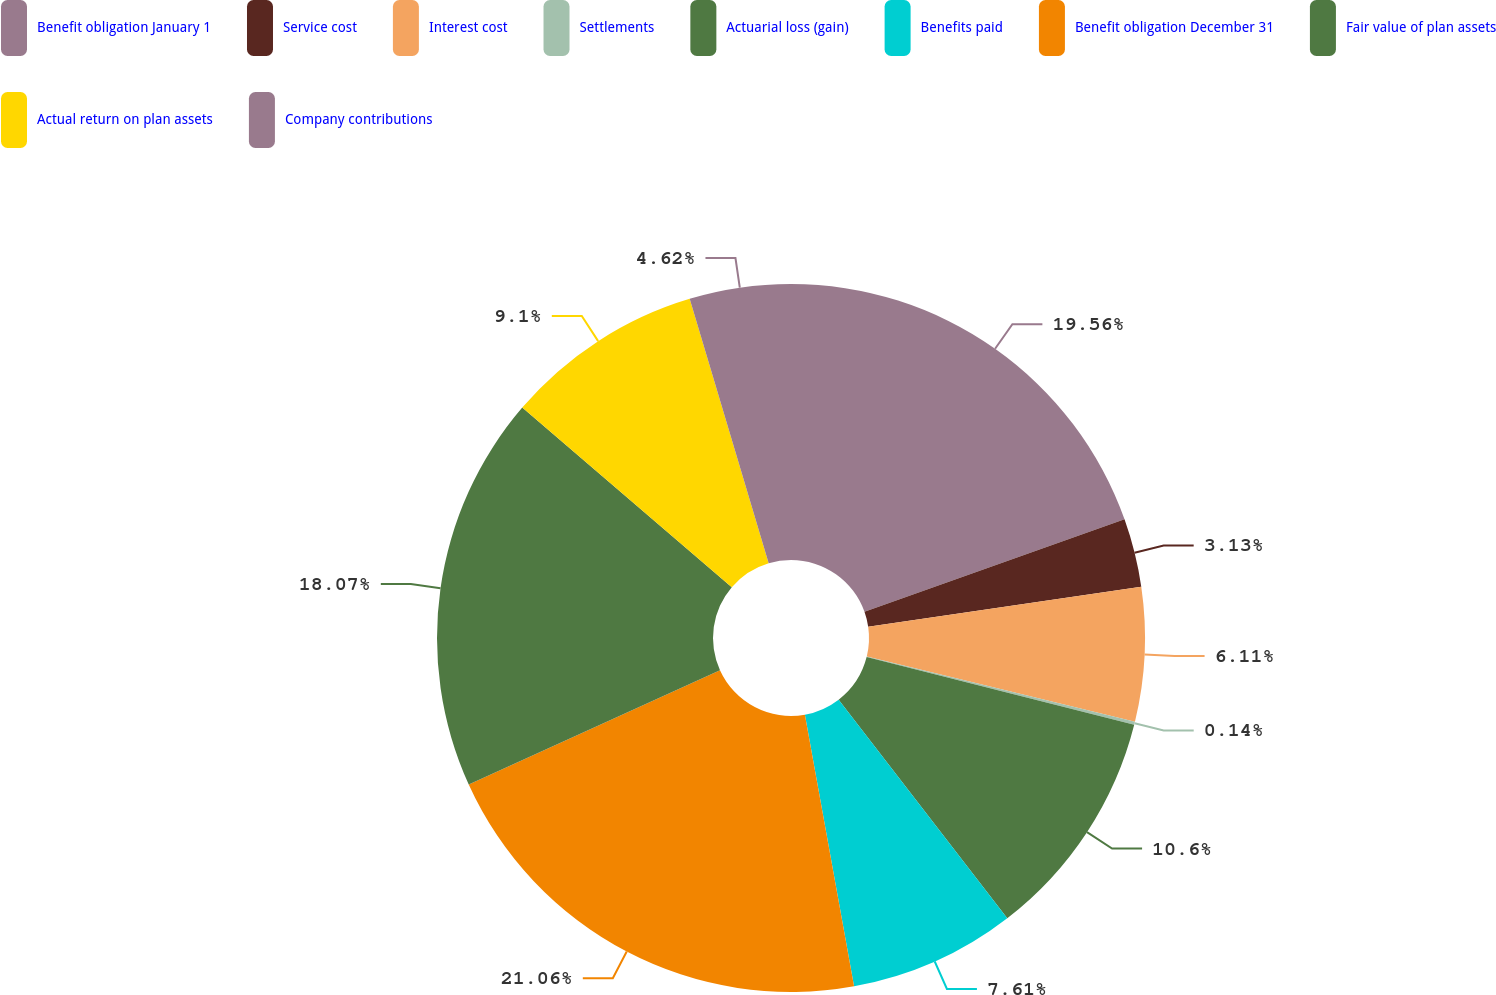Convert chart to OTSL. <chart><loc_0><loc_0><loc_500><loc_500><pie_chart><fcel>Benefit obligation January 1<fcel>Service cost<fcel>Interest cost<fcel>Settlements<fcel>Actuarial loss (gain)<fcel>Benefits paid<fcel>Benefit obligation December 31<fcel>Fair value of plan assets<fcel>Actual return on plan assets<fcel>Company contributions<nl><fcel>19.56%<fcel>3.13%<fcel>6.11%<fcel>0.14%<fcel>10.6%<fcel>7.61%<fcel>21.06%<fcel>18.07%<fcel>9.1%<fcel>4.62%<nl></chart> 